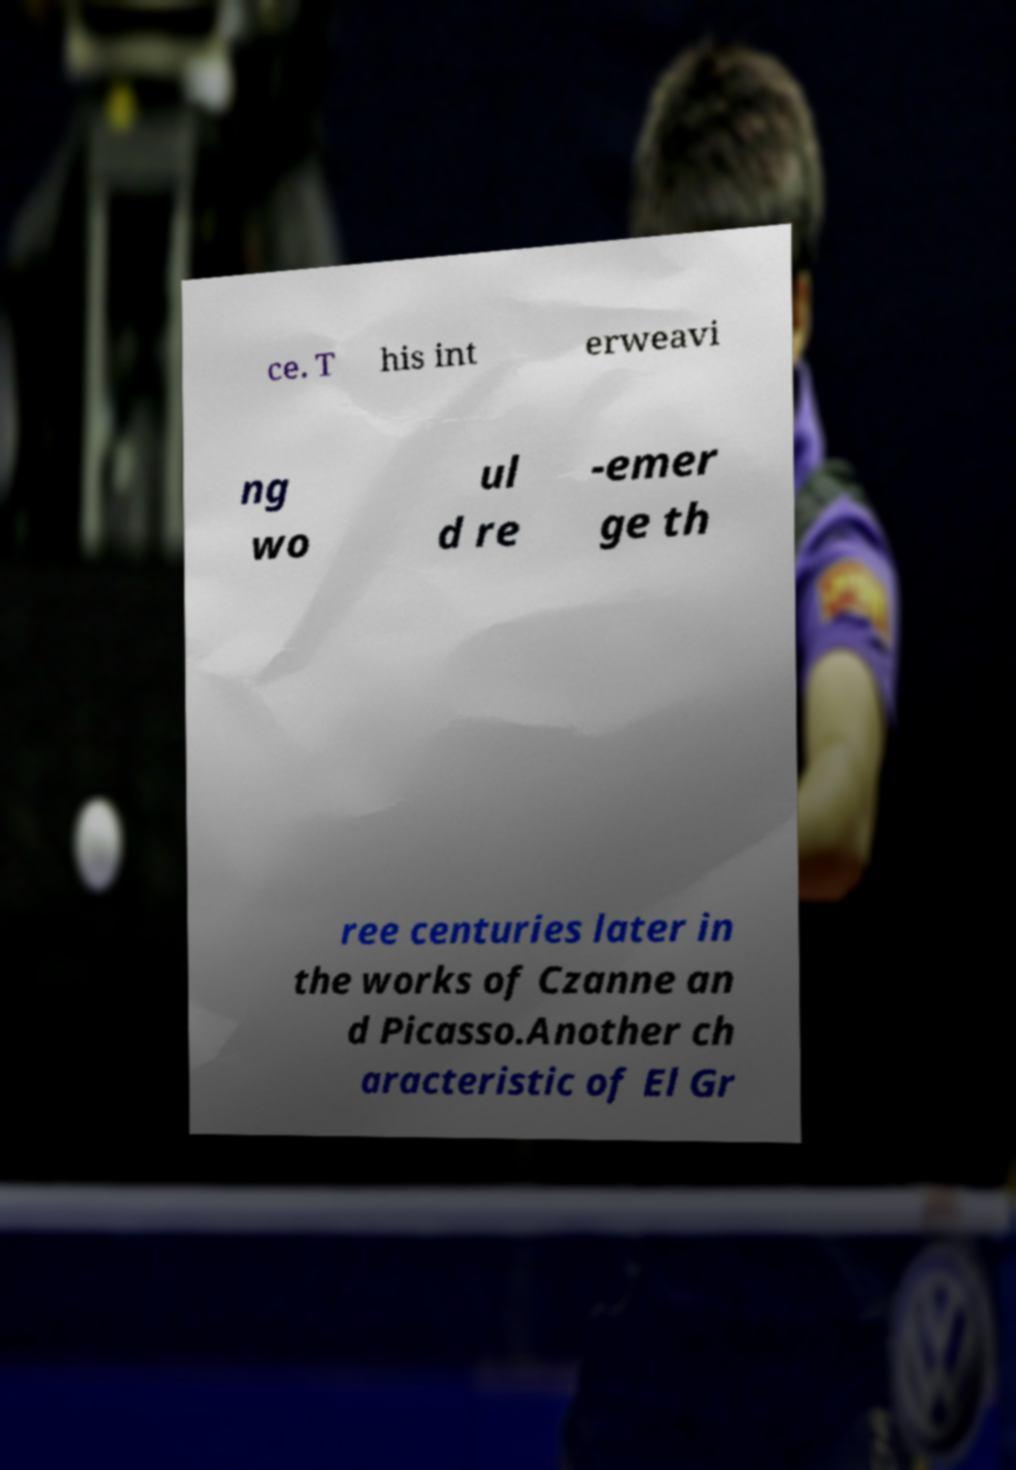I need the written content from this picture converted into text. Can you do that? ce. T his int erweavi ng wo ul d re -emer ge th ree centuries later in the works of Czanne an d Picasso.Another ch aracteristic of El Gr 